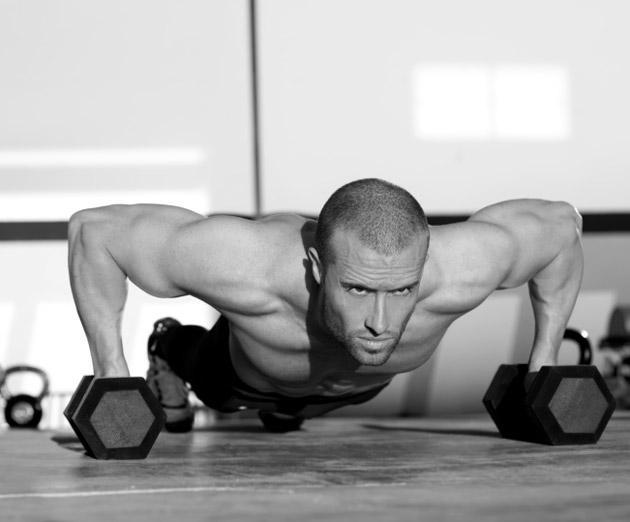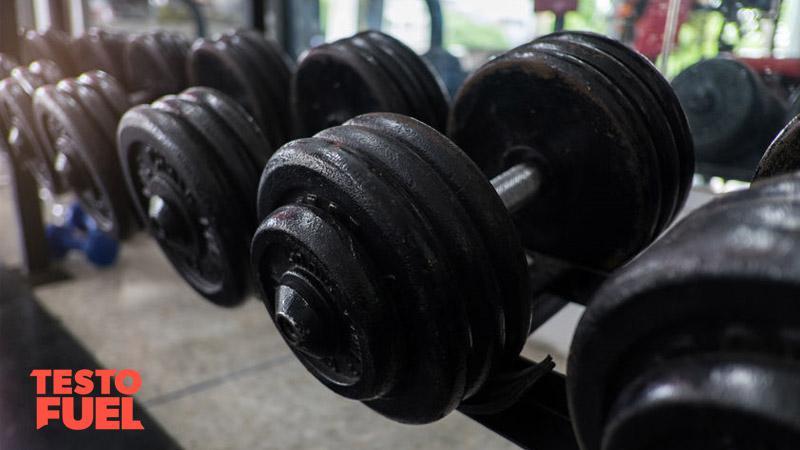The first image is the image on the left, the second image is the image on the right. For the images shown, is this caption "One image shows a human doing pushups." true? Answer yes or no. Yes. The first image is the image on the left, the second image is the image on the right. Given the left and right images, does the statement "There is at least one man visible exercising" hold true? Answer yes or no. Yes. 